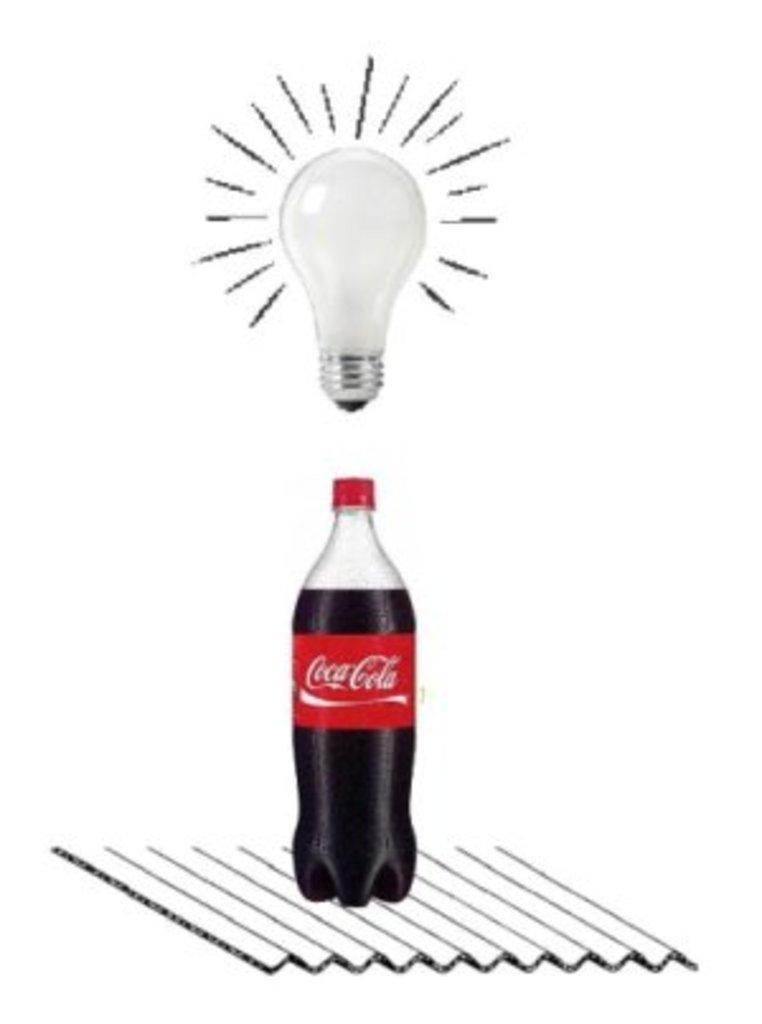Could you give a brief overview of what you see in this image? This picture contains a cool drink bottle and a sticker is pasted on it with text as 'Coca Cola'. Above the bottle, we see red color lid and above the light, we see white bulb. 